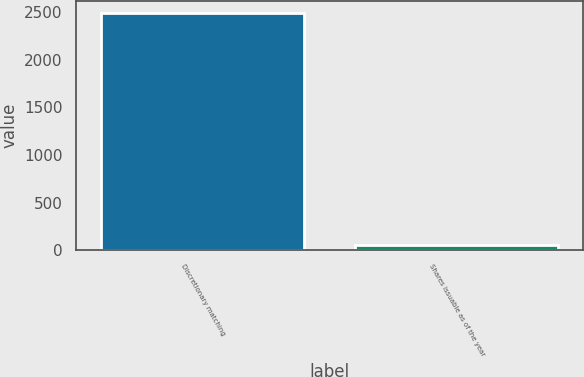Convert chart. <chart><loc_0><loc_0><loc_500><loc_500><bar_chart><fcel>Discretionary matching<fcel>Shares issuable as of the year<nl><fcel>2492<fcel>57<nl></chart> 